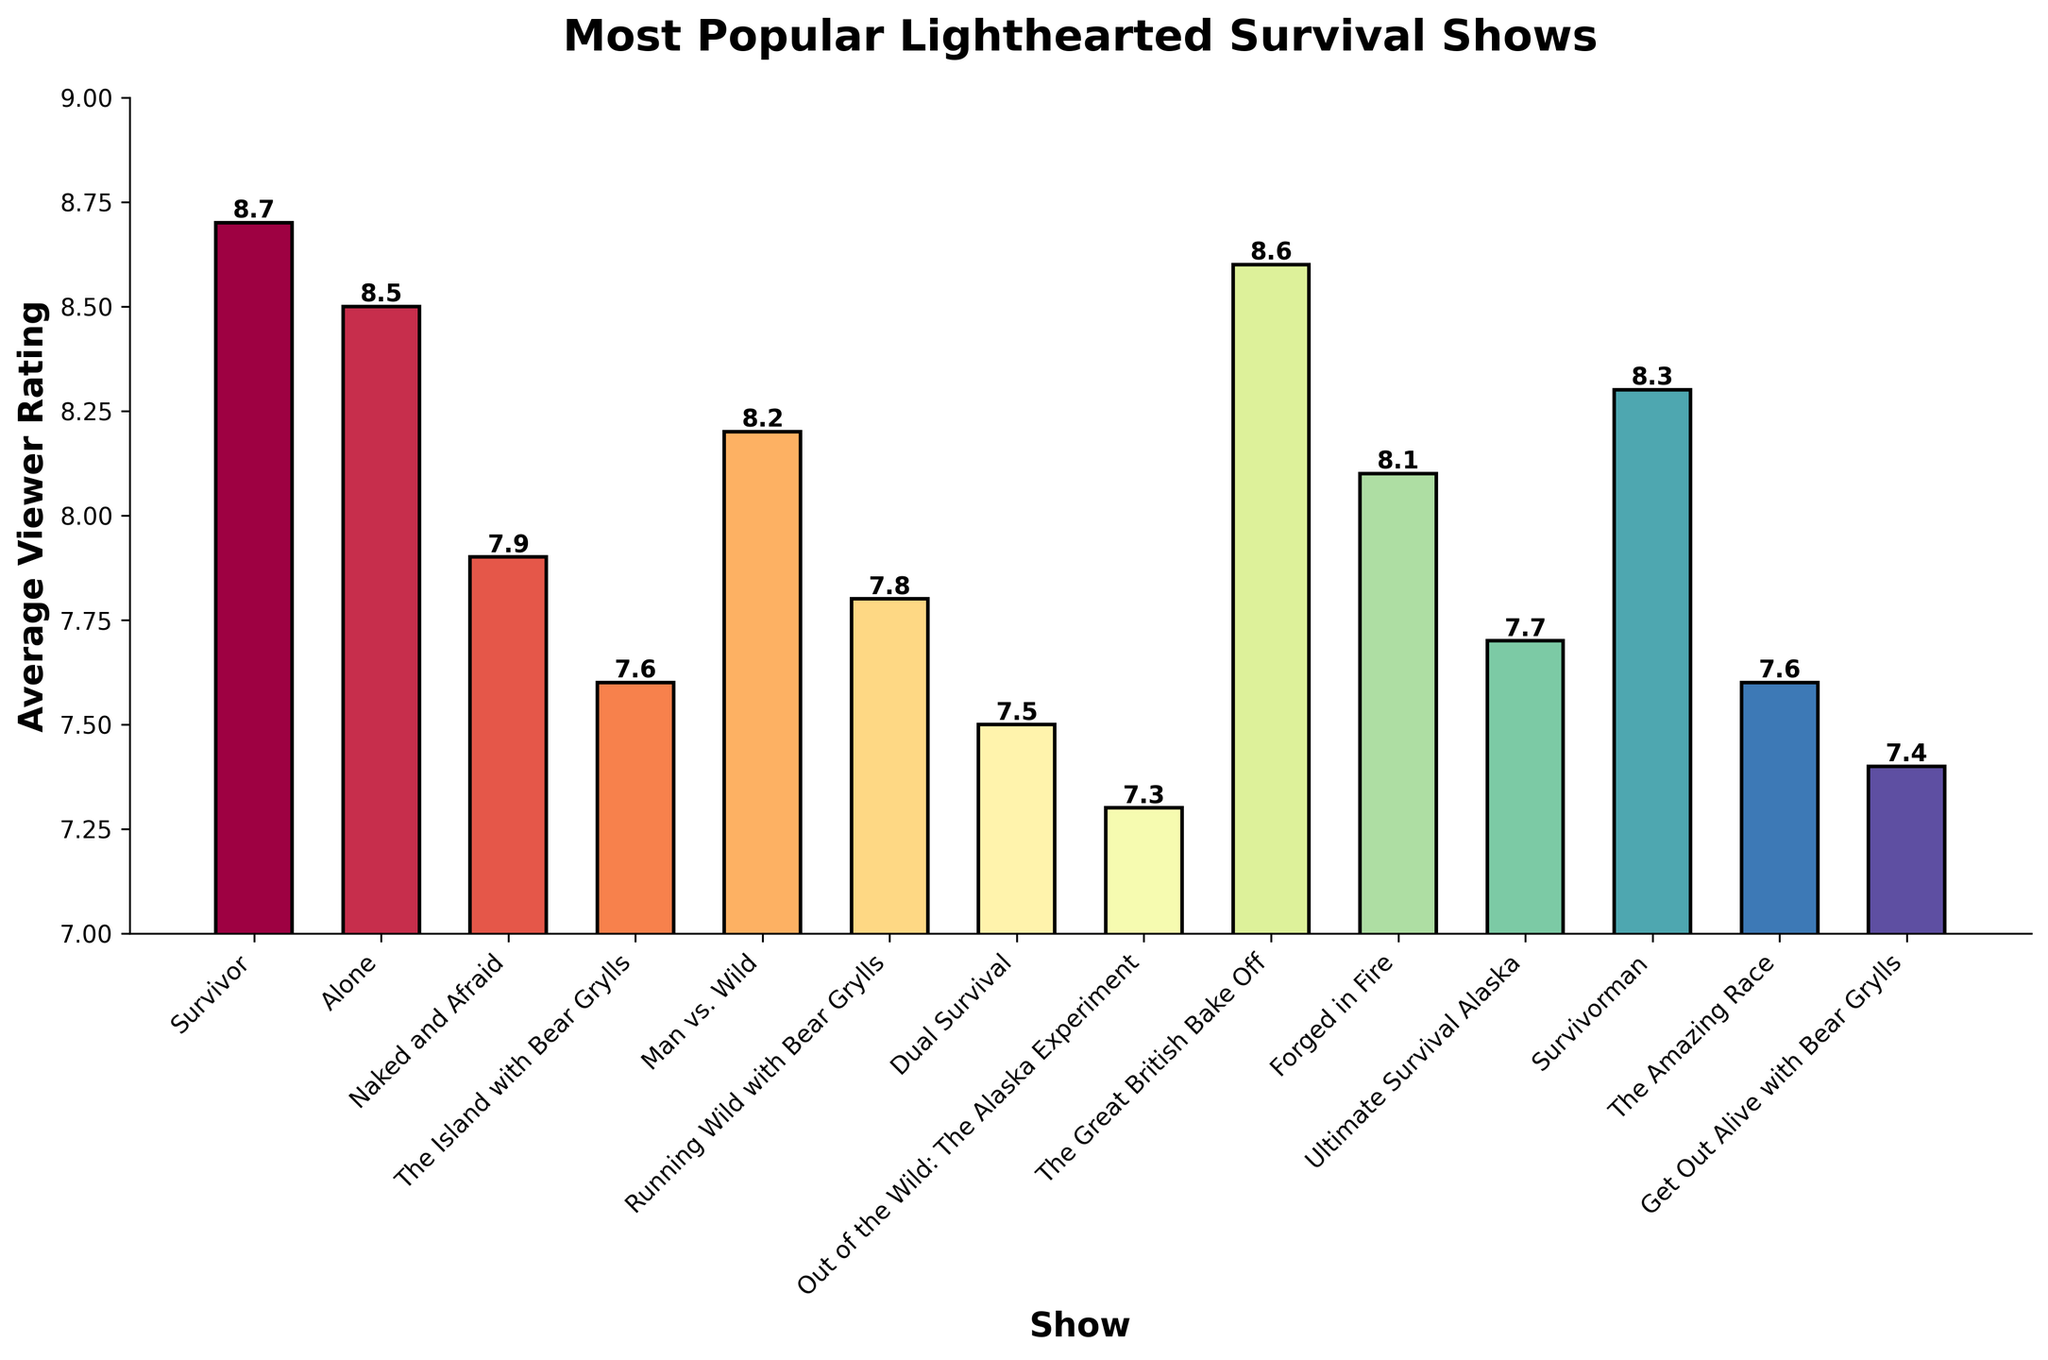Which show has the highest average viewer rating? The highest bar represents the show with the highest average viewer rating, labelled Survivor with a rating of 8.7
Answer: Survivor Which show has the lowest average viewer rating? The lowest bar represents the show with the lowest average viewer rating, labelled Out of the Wild: The Alaska Experiment with a rating of 7.3
Answer: Out of the Wild: The Alaska Experiment What is the difference in average viewer rating between Survivor and Out of the Wild: The Alaska Experiment? The average viewer rating of Survivor is 8.7 and Out of the Wild: The Alaska Experiment is 7.3. The difference is 8.7 - 7.3 = 1.4
Answer: 1.4 Which show has a higher rating, Man vs. Wild or Ultimate Survival Alaska? By comparing the heights of the two specific bars, Man vs. Wild has a rating of 8.2, whereas Ultimate Survival Alaska has a rating of 7.7. 8.2 is greater than 7.7
Answer: Man vs. Wild How many shows have an average viewer rating greater than 8.0? Counting all bars with a height above 8.0, there are 6 shows: Survivor, Alone, The Great British Bake Off, Man vs. Wild, Forged in Fire, and Survivorman
Answer: 6 Which shows have the same average viewer rating? Observing the bars that are at the same height, The Island with Bear Grylls and The Amazing Race both have ratings of 7.6
Answer: The Island with Bear Grylls, The Amazing Race What is the combined average viewer rating of Dual Survival and The Amazing Race? The average viewer rating for Dual Survival is 7.5 and for The Amazing Race is 7.6. The combined rating is 7.5 + 7.6 = 15.1
Answer: 15.1 What is the difference in viewer ratings between Running Wild with Bear Grylls and Get Out Alive with Bear Grylls? The average viewer rating for Running Wild with Bear Grylls is 7.8 and for Get Out Alive with Bear Grylls is 7.4. The difference is 7.8 - 7.4 = 0.4
Answer: 0.4 Which show has a higher rating, Alone or Naked and Afraid? By comparing the heights of the two specific bars, Alone has a rating of 8.5, whereas Naked and Afraid has a rating of 7.9. 8.5 is greater than 7.9
Answer: Alone What is the average rating of the top three shows? The top three shows by viewer rating are Survivor (8.7), The Great British Bake Off (8.6), and Alone (8.5). The average rating is (8.7 + 8.6 + 8.5) / 3 = 25.8 / 3 = 8.6
Answer: 8.6 